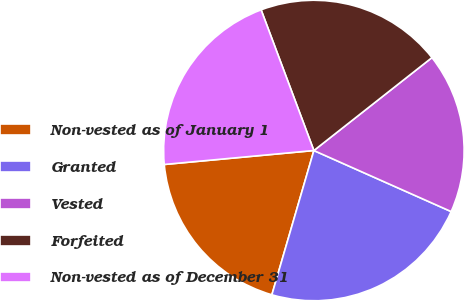Convert chart to OTSL. <chart><loc_0><loc_0><loc_500><loc_500><pie_chart><fcel>Non-vested as of January 1<fcel>Granted<fcel>Vested<fcel>Forfeited<fcel>Non-vested as of December 31<nl><fcel>19.01%<fcel>22.85%<fcel>17.27%<fcel>20.1%<fcel>20.77%<nl></chart> 